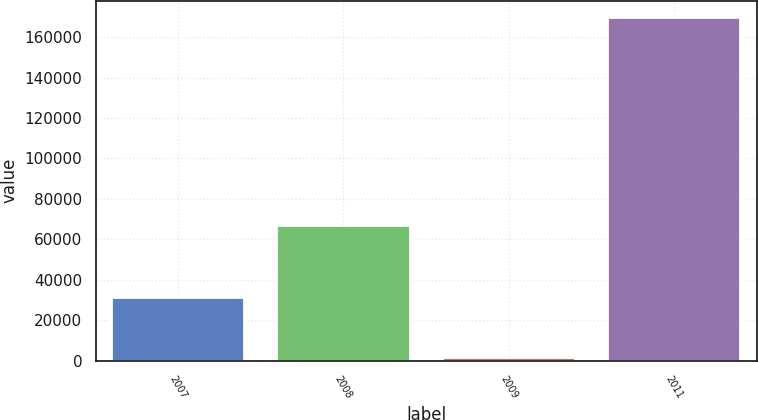Convert chart to OTSL. <chart><loc_0><loc_0><loc_500><loc_500><bar_chart><fcel>2007<fcel>2008<fcel>2009<fcel>2011<nl><fcel>31022<fcel>66488<fcel>1291<fcel>169591<nl></chart> 